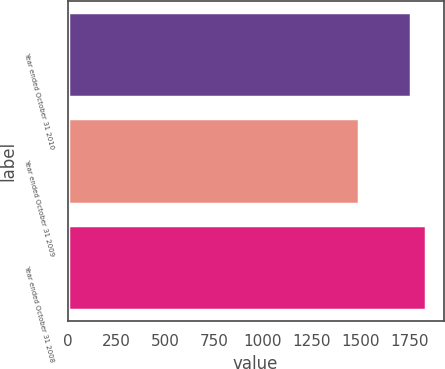Convert chart. <chart><loc_0><loc_0><loc_500><loc_500><bar_chart><fcel>Year ended October 31 2010<fcel>Year ended October 31 2009<fcel>Year ended October 31 2008<nl><fcel>1760<fcel>1495<fcel>1834<nl></chart> 